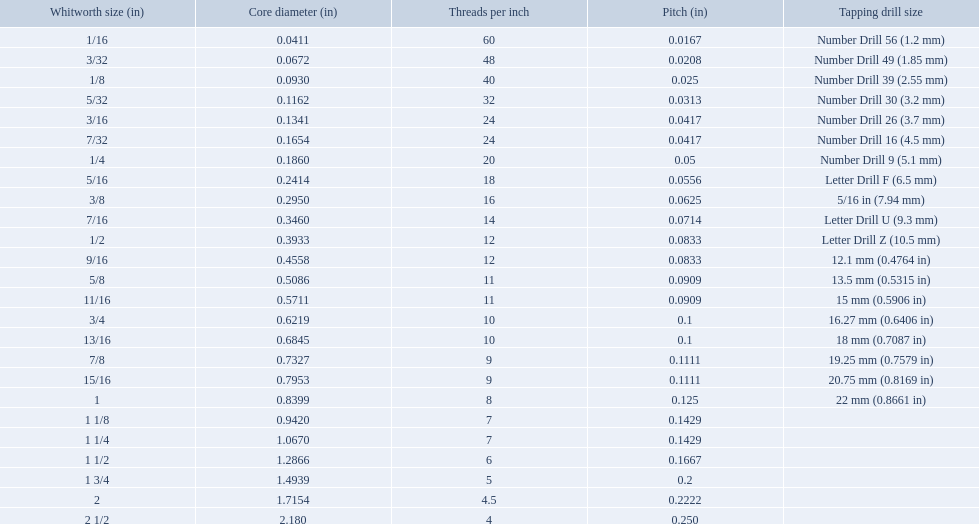What are all of the whitworth sizes? 1/16, 3/32, 1/8, 5/32, 3/16, 7/32, 1/4, 5/16, 3/8, 7/16, 1/2, 9/16, 5/8, 11/16, 3/4, 13/16, 7/8, 15/16, 1, 1 1/8, 1 1/4, 1 1/2, 1 3/4, 2, 2 1/2. How many threads per inch are in each size? 60, 48, 40, 32, 24, 24, 20, 18, 16, 14, 12, 12, 11, 11, 10, 10, 9, 9, 8, 7, 7, 6, 5, 4.5, 4. How many threads per inch are in the 3/16 size? 24. And which other size has the same number of threads? 7/32. A 1/16 whitworth has a core diameter of? 0.0411. Which whiteworth size has the same pitch as a 1/2? 9/16. 3/16 whiteworth has the same number of threads as? 7/32. What are all the whitworth sizes? 1/16, 3/32, 1/8, 5/32, 3/16, 7/32, 1/4, 5/16, 3/8, 7/16, 1/2, 9/16, 5/8, 11/16, 3/4, 13/16, 7/8, 15/16, 1, 1 1/8, 1 1/4, 1 1/2, 1 3/4, 2, 2 1/2. What are the threads per inch of these sizes? 60, 48, 40, 32, 24, 24, 20, 18, 16, 14, 12, 12, 11, 11, 10, 10, 9, 9, 8, 7, 7, 6, 5, 4.5, 4. Of these, which are 5? 5. What whitworth size has this threads per inch? 1 3/4. What are all of the whitworth sizes in the british standard whitworth? 1/16, 3/32, 1/8, 5/32, 3/16, 7/32, 1/4, 5/16, 3/8, 7/16, 1/2, 9/16, 5/8, 11/16, 3/4, 13/16, 7/8, 15/16, 1, 1 1/8, 1 1/4, 1 1/2, 1 3/4, 2, 2 1/2. Which of these sizes uses a tapping drill size of 26? 3/16. What is the core diameter for the number drill 26? 0.1341. What is the whitworth size (in) for this core diameter? 3/16. What was the core diameter of a number drill 26 0.1341. What is this measurement in whitworth size? 3/16. What are the conventional whitworth sizes in inches? 1/16, 3/32, 1/8, 5/32, 3/16, 7/32, 1/4, 5/16, 3/8, 7/16, 1/2, 9/16, 5/8, 11/16, 3/4, 13/16, 7/8, 15/16, 1, 1 1/8, 1 1/4, 1 1/2, 1 3/4, 2, 2 1/2. How many threads per inch does the 3/16 size contain? 24. Which size (in inches) has an identical number of threads? 7/32. What are every whitworth dimension? 1/16, 3/32, 1/8, 5/32, 3/16, 7/32, 1/4, 5/16, 3/8, 7/16, 1/2, 9/16, 5/8, 11/16, 3/4, 13/16, 7/8, 15/16, 1, 1 1/8, 1 1/4, 1 1/2, 1 3/4, 2, 2 1/2. What is the thread count per inch for these dimensions? 60, 48, 40, 32, 24, 24, 20, 18, 16, 14, 12, 12, 11, 11, 10, 10, 9, 9, 8, 7, 7, 6, 5, 4.5, 4. Among these, which ones are 5? 5. Which whitworth dimension has this thread count per inch? 1 3/4. What are the complete whitworth dimensions? 1/16, 3/32, 1/8, 5/32, 3/16, 7/32, 1/4, 5/16, 3/8, 7/16, 1/2, 9/16, 5/8, 11/16, 3/4, 13/16, 7/8, 15/16, 1, 1 1/8, 1 1/4, 1 1/2, 1 3/4, 2, 2 1/2. How many threads per inch exist in each dimension? 60, 48, 40, 32, 24, 24, 20, 18, 16, 14, 12, 12, 11, 11, 10, 10, 9, 9, 8, 7, 7, 6, 5, 4.5, 4. How many threads per inch are present in the 3/16 dimension? 24. And which other dimension possesses an equal number of threads? 7/32. What are all the whitworth measurements in the british standard whitworth? 1/16, 3/32, 1/8, 5/32, 3/16, 7/32, 1/4, 5/16, 3/8, 7/16, 1/2, 9/16, 5/8, 11/16, 3/4, 13/16, 7/8, 15/16, 1, 1 1/8, 1 1/4, 1 1/2, 1 3/4, 2, 2 1/2. Which of these measurements utilizes a tapping drill size of 26? 3/16. What are the measurements of threads per inch? 60, 48, 40, 32, 24, 24, 20, 18, 16, 14, 12, 12, 11, 11, 10, 10, 9, 9, 8, 7, 7, 6, 5, 4.5, 4. Which whitworth measurement has only 5 threads per inch? 1 3/4. What's the central diameter for a 1/16 whitworth? 0.0411. Which whitworth measurement has the same pitch as a 1/2? 9/16. A 3/16 whitworth has an equal amount of threads as? 7/32. What are the standard inch-based whitworth sizes? 1/16, 3/32, 1/8, 5/32, 3/16, 7/32, 1/4, 5/16, 3/8, 7/16, 1/2, 9/16, 5/8, 11/16, 3/4, 13/16, 7/8, 15/16, 1, 1 1/8, 1 1/4, 1 1/2, 1 3/4, 2, 2 1/2. How many threads per inch can be found in the 3/16 size? 24. Is there another inch-based size with the same thread quantity? 7/32. 